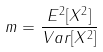Convert formula to latex. <formula><loc_0><loc_0><loc_500><loc_500>m = \frac { E ^ { 2 } [ X ^ { 2 } ] } { V a r [ X ^ { 2 } ] }</formula> 